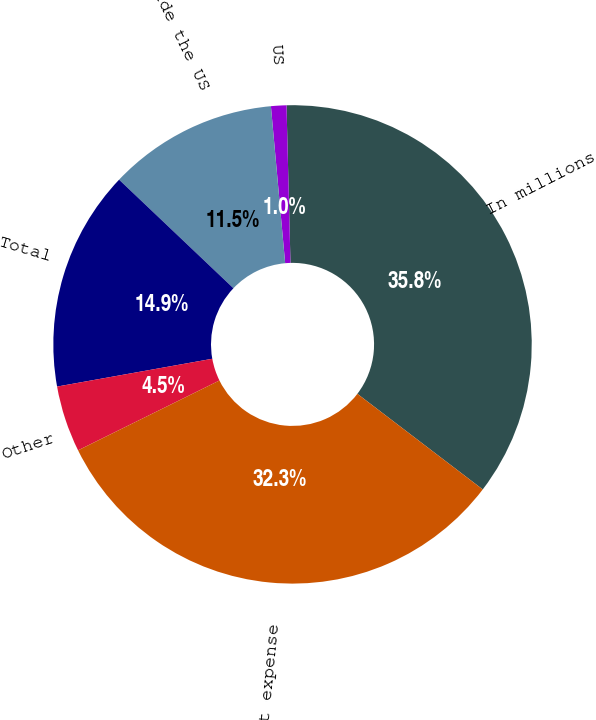Convert chart. <chart><loc_0><loc_0><loc_500><loc_500><pie_chart><fcel>In millions<fcel>US<fcel>Outside the US<fcel>Total<fcel>Other<fcel>Total rent expense<nl><fcel>35.77%<fcel>1.04%<fcel>11.47%<fcel>14.91%<fcel>4.48%<fcel>32.33%<nl></chart> 